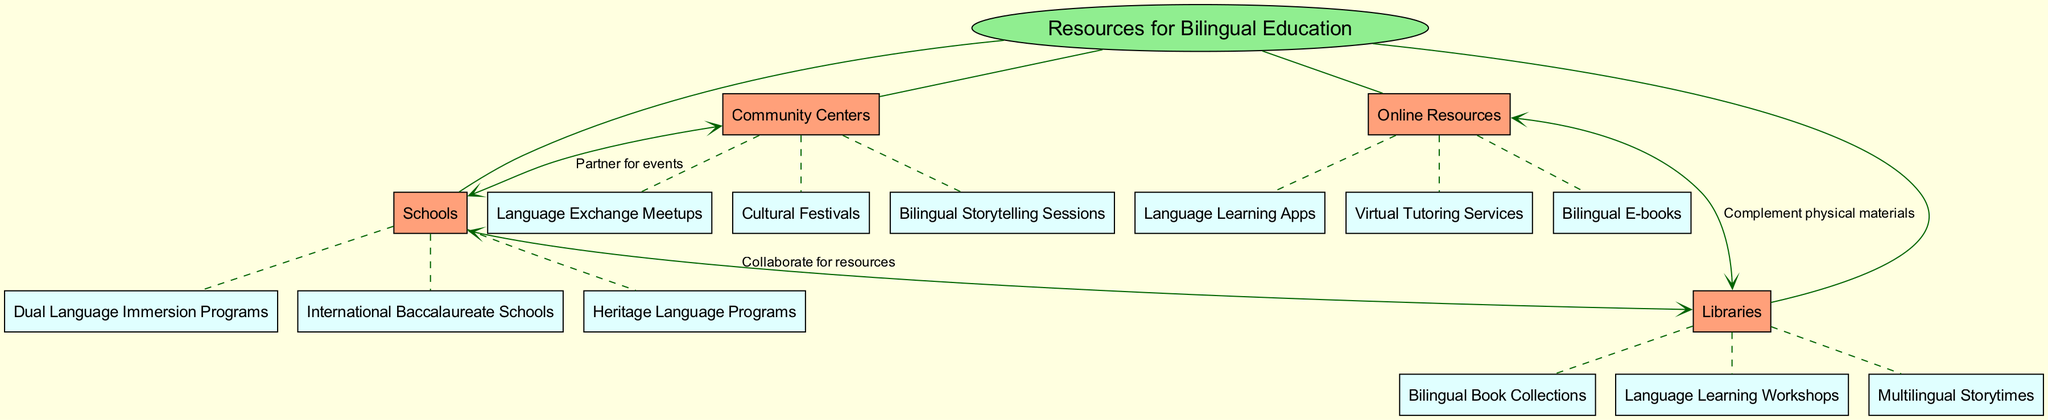What is the central topic of the diagram? The central topic is explicitly labeled in the diagram as "Resources for Bilingual Education."
Answer: Resources for Bilingual Education How many main branches are there in the diagram? By counting the main branches under the central topic, I see that there are four branches: Schools, Community Centers, Online Resources, and Libraries.
Answer: 4 What is one type of program found under Schools? The diagram lists three subnodes under Schools, one of which is "Dual Language Immersion Programs."
Answer: Dual Language Immersion Programs What do Community Centers partner with Schools for? The connections in the diagram indicate the relationship where Community Centers partner with Schools for "events."
Answer: events Which resource type complements physical materials from Libraries? The connection labeled in the diagram shows that Online Resources serve to complement physical materials from Libraries.
Answer: Online Resources What is the relationship between Online Resources and Libraries? The diagram specifies that Online Resources complement physical materials, showing a supportive relationship between the two nodes.
Answer: Complement physical materials How many subnodes are listed under Libraries? Upon reviewing the Libraries branch, it shows three subnodes: Bilingual Book Collections, Language Learning Workshops, and Multilingual Storytimes.
Answer: 3 Which main branch has a connection labeled "Collaborate for resources"? Looking at the connections section of the diagram, the connection labeled "Collaborate for resources" is between Schools and Libraries.
Answer: Schools What type of sessions does Community Centers offer? The subnodes under the Community Centers branch indicate that they offer "Bilingual Storytelling Sessions."
Answer: Bilingual Storytelling Sessions 